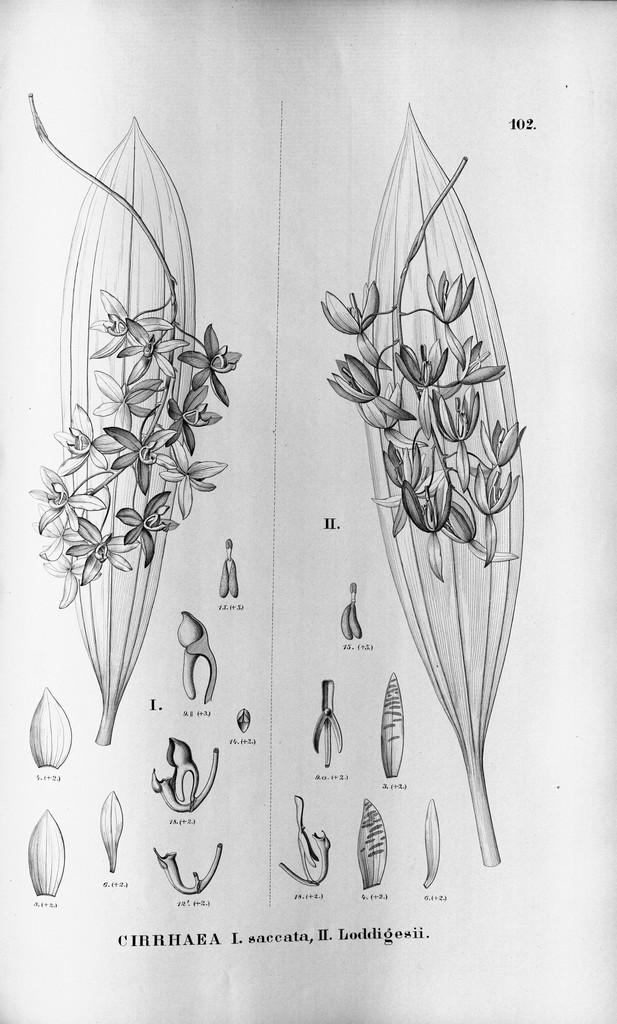What is the main subject of the image? The image contains an art piece. What is depicted in the art piece? The art piece depicts flowers on leaves. Are there any specific features of the flowers in the art piece? Yes, there are buds at the bottom of the art piece. What type of oven is used to cook the flowers in the image? There is no oven present in the image, as it features an art piece depicting flowers on leaves. 